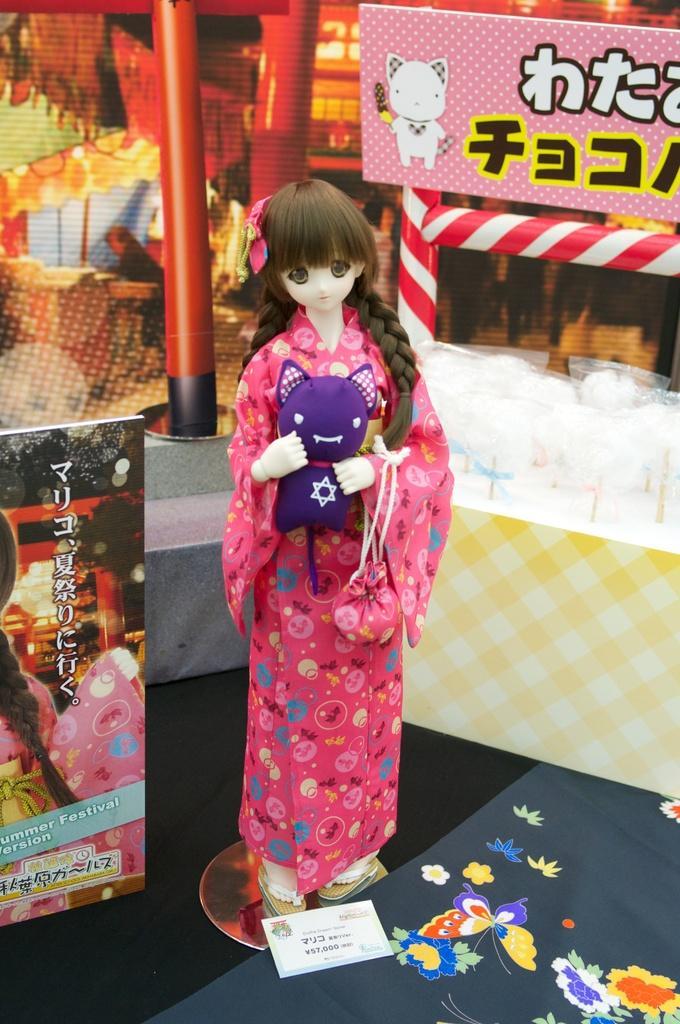How would you summarize this image in a sentence or two? In this image we can see a Barbie doll on the display. 